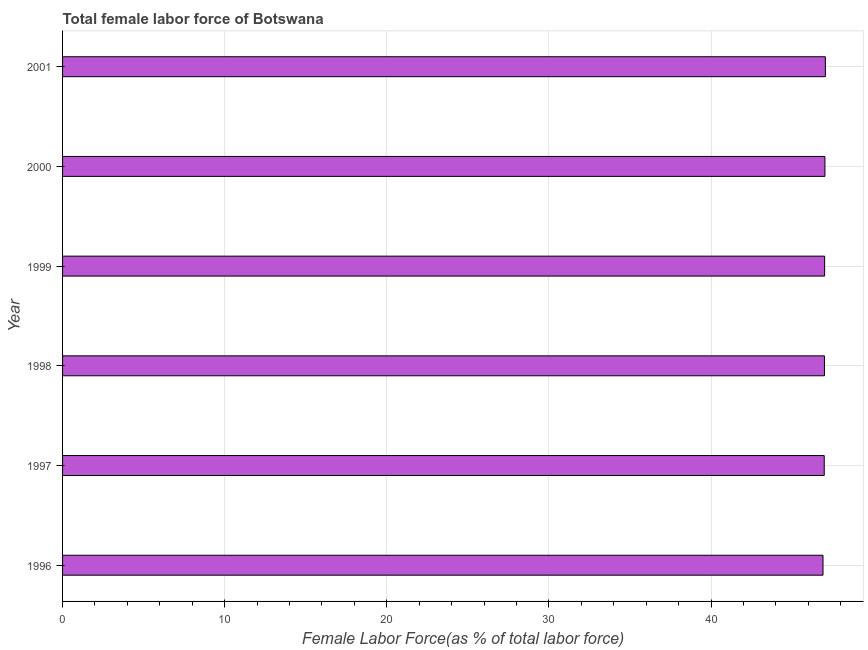Does the graph contain any zero values?
Your answer should be very brief. No. What is the title of the graph?
Your answer should be compact. Total female labor force of Botswana. What is the label or title of the X-axis?
Offer a very short reply. Female Labor Force(as % of total labor force). What is the label or title of the Y-axis?
Your response must be concise. Year. What is the total female labor force in 1997?
Offer a terse response. 46.98. Across all years, what is the maximum total female labor force?
Offer a very short reply. 47.05. Across all years, what is the minimum total female labor force?
Offer a terse response. 46.91. In which year was the total female labor force maximum?
Offer a very short reply. 2001. In which year was the total female labor force minimum?
Your answer should be compact. 1996. What is the sum of the total female labor force?
Offer a terse response. 281.96. What is the difference between the total female labor force in 1998 and 2001?
Make the answer very short. -0.06. What is the average total female labor force per year?
Your answer should be very brief. 46.99. What is the median total female labor force?
Your response must be concise. 47. In how many years, is the total female labor force greater than 12 %?
Make the answer very short. 6. Is the total female labor force in 1996 less than that in 1999?
Your answer should be very brief. Yes. What is the difference between the highest and the second highest total female labor force?
Ensure brevity in your answer.  0.03. Is the sum of the total female labor force in 2000 and 2001 greater than the maximum total female labor force across all years?
Make the answer very short. Yes. What is the difference between the highest and the lowest total female labor force?
Offer a very short reply. 0.14. In how many years, is the total female labor force greater than the average total female labor force taken over all years?
Ensure brevity in your answer.  4. How many years are there in the graph?
Ensure brevity in your answer.  6. What is the Female Labor Force(as % of total labor force) in 1996?
Offer a terse response. 46.91. What is the Female Labor Force(as % of total labor force) of 1997?
Provide a succinct answer. 46.98. What is the Female Labor Force(as % of total labor force) in 1998?
Ensure brevity in your answer.  46.99. What is the Female Labor Force(as % of total labor force) of 1999?
Keep it short and to the point. 47. What is the Female Labor Force(as % of total labor force) in 2000?
Your response must be concise. 47.02. What is the Female Labor Force(as % of total labor force) in 2001?
Offer a terse response. 47.05. What is the difference between the Female Labor Force(as % of total labor force) in 1996 and 1997?
Offer a terse response. -0.08. What is the difference between the Female Labor Force(as % of total labor force) in 1996 and 1998?
Provide a succinct answer. -0.09. What is the difference between the Female Labor Force(as % of total labor force) in 1996 and 1999?
Your answer should be very brief. -0.1. What is the difference between the Female Labor Force(as % of total labor force) in 1996 and 2000?
Offer a terse response. -0.12. What is the difference between the Female Labor Force(as % of total labor force) in 1996 and 2001?
Ensure brevity in your answer.  -0.14. What is the difference between the Female Labor Force(as % of total labor force) in 1997 and 1998?
Your answer should be very brief. -0.01. What is the difference between the Female Labor Force(as % of total labor force) in 1997 and 1999?
Your answer should be compact. -0.02. What is the difference between the Female Labor Force(as % of total labor force) in 1997 and 2000?
Keep it short and to the point. -0.04. What is the difference between the Female Labor Force(as % of total labor force) in 1997 and 2001?
Offer a terse response. -0.07. What is the difference between the Female Labor Force(as % of total labor force) in 1998 and 1999?
Give a very brief answer. -0.01. What is the difference between the Female Labor Force(as % of total labor force) in 1998 and 2000?
Ensure brevity in your answer.  -0.03. What is the difference between the Female Labor Force(as % of total labor force) in 1998 and 2001?
Your answer should be compact. -0.06. What is the difference between the Female Labor Force(as % of total labor force) in 1999 and 2000?
Your answer should be compact. -0.02. What is the difference between the Female Labor Force(as % of total labor force) in 1999 and 2001?
Keep it short and to the point. -0.05. What is the difference between the Female Labor Force(as % of total labor force) in 2000 and 2001?
Provide a succinct answer. -0.03. What is the ratio of the Female Labor Force(as % of total labor force) in 1996 to that in 1998?
Your answer should be compact. 1. What is the ratio of the Female Labor Force(as % of total labor force) in 1997 to that in 2000?
Your answer should be very brief. 1. What is the ratio of the Female Labor Force(as % of total labor force) in 1998 to that in 1999?
Your answer should be very brief. 1. What is the ratio of the Female Labor Force(as % of total labor force) in 1998 to that in 2000?
Your answer should be compact. 1. What is the ratio of the Female Labor Force(as % of total labor force) in 1998 to that in 2001?
Ensure brevity in your answer.  1. What is the ratio of the Female Labor Force(as % of total labor force) in 1999 to that in 2000?
Keep it short and to the point. 1. What is the ratio of the Female Labor Force(as % of total labor force) in 2000 to that in 2001?
Give a very brief answer. 1. 